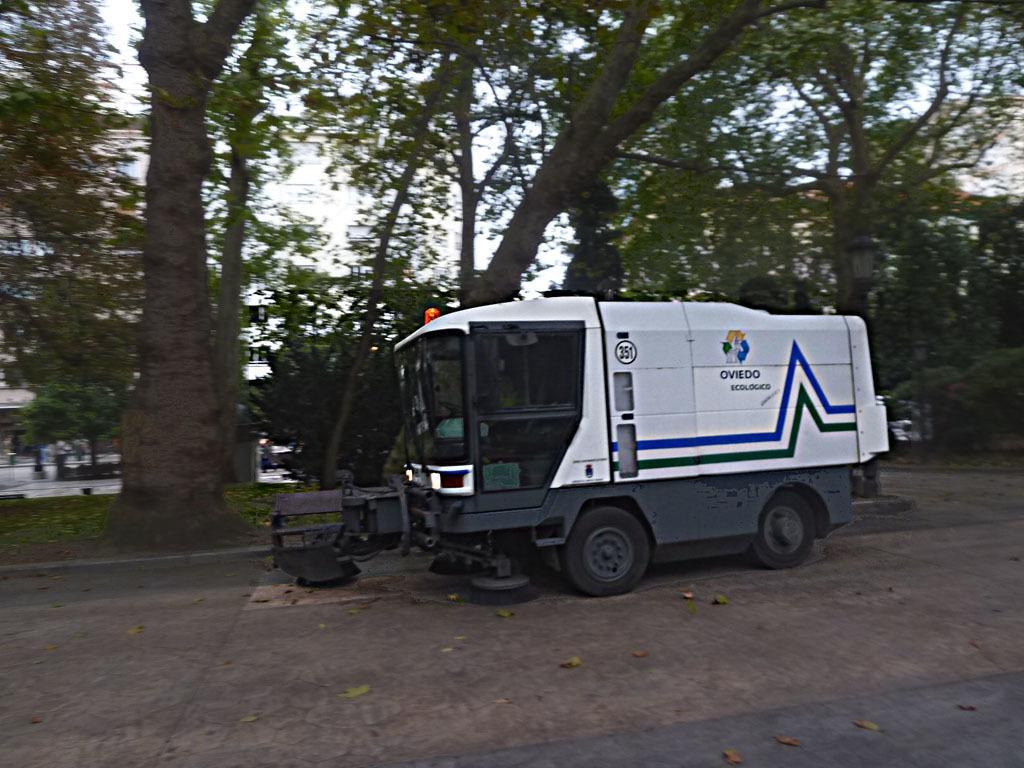How would you summarize this image in a sentence or two? In this image there is a road sweeper on a road, in the background there are trees. 